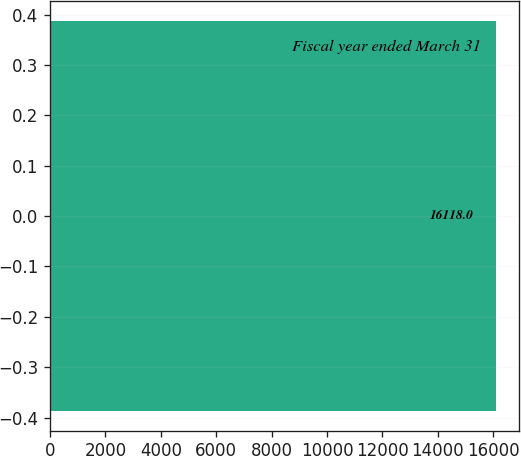<chart> <loc_0><loc_0><loc_500><loc_500><bar_chart><fcel>Fiscal year ended March 31<nl><fcel>16118<nl></chart> 